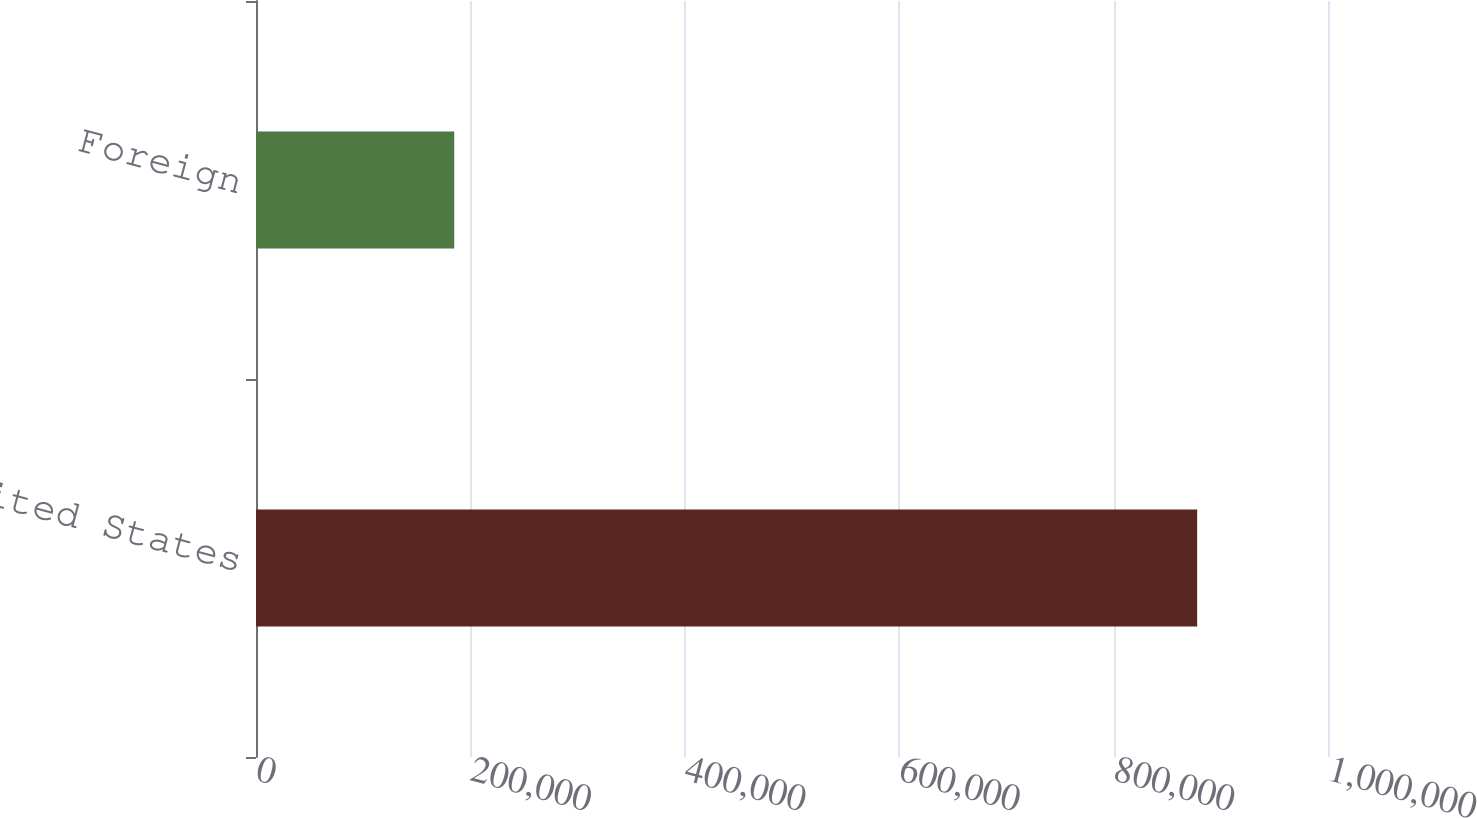Convert chart. <chart><loc_0><loc_0><loc_500><loc_500><bar_chart><fcel>United States<fcel>Foreign<nl><fcel>877949<fcel>184916<nl></chart> 